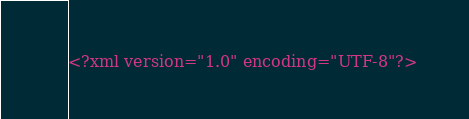Convert code to text. <code><loc_0><loc_0><loc_500><loc_500><_XML_><?xml version="1.0" encoding="UTF-8"?></code> 